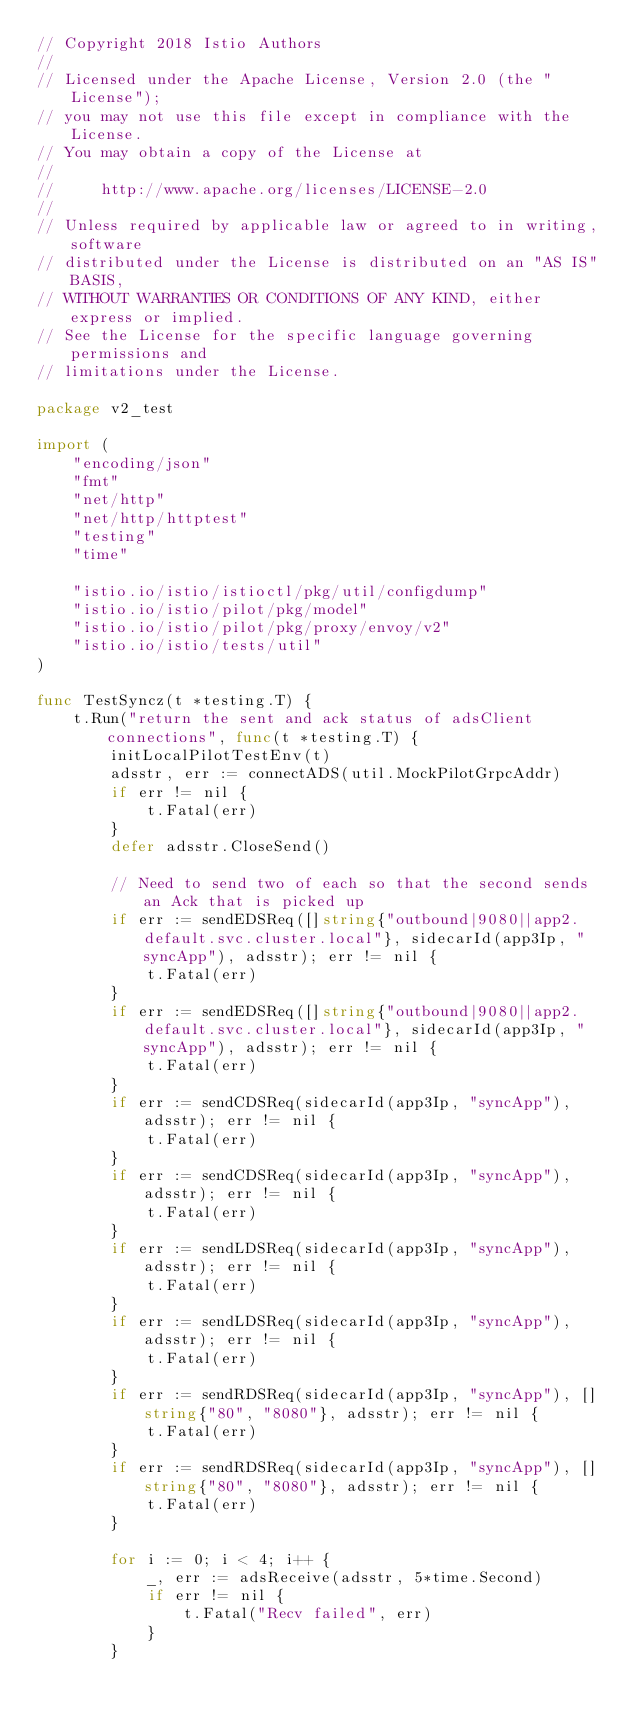Convert code to text. <code><loc_0><loc_0><loc_500><loc_500><_Go_>// Copyright 2018 Istio Authors
//
// Licensed under the Apache License, Version 2.0 (the "License");
// you may not use this file except in compliance with the License.
// You may obtain a copy of the License at
//
//     http://www.apache.org/licenses/LICENSE-2.0
//
// Unless required by applicable law or agreed to in writing, software
// distributed under the License is distributed on an "AS IS" BASIS,
// WITHOUT WARRANTIES OR CONDITIONS OF ANY KIND, either express or implied.
// See the License for the specific language governing permissions and
// limitations under the License.

package v2_test

import (
	"encoding/json"
	"fmt"
	"net/http"
	"net/http/httptest"
	"testing"
	"time"

	"istio.io/istio/istioctl/pkg/util/configdump"
	"istio.io/istio/pilot/pkg/model"
	"istio.io/istio/pilot/pkg/proxy/envoy/v2"
	"istio.io/istio/tests/util"
)

func TestSyncz(t *testing.T) {
	t.Run("return the sent and ack status of adsClient connections", func(t *testing.T) {
		initLocalPilotTestEnv(t)
		adsstr, err := connectADS(util.MockPilotGrpcAddr)
		if err != nil {
			t.Fatal(err)
		}
		defer adsstr.CloseSend()

		// Need to send two of each so that the second sends an Ack that is picked up
		if err := sendEDSReq([]string{"outbound|9080||app2.default.svc.cluster.local"}, sidecarId(app3Ip, "syncApp"), adsstr); err != nil {
			t.Fatal(err)
		}
		if err := sendEDSReq([]string{"outbound|9080||app2.default.svc.cluster.local"}, sidecarId(app3Ip, "syncApp"), adsstr); err != nil {
			t.Fatal(err)
		}
		if err := sendCDSReq(sidecarId(app3Ip, "syncApp"), adsstr); err != nil {
			t.Fatal(err)
		}
		if err := sendCDSReq(sidecarId(app3Ip, "syncApp"), adsstr); err != nil {
			t.Fatal(err)
		}
		if err := sendLDSReq(sidecarId(app3Ip, "syncApp"), adsstr); err != nil {
			t.Fatal(err)
		}
		if err := sendLDSReq(sidecarId(app3Ip, "syncApp"), adsstr); err != nil {
			t.Fatal(err)
		}
		if err := sendRDSReq(sidecarId(app3Ip, "syncApp"), []string{"80", "8080"}, adsstr); err != nil {
			t.Fatal(err)
		}
		if err := sendRDSReq(sidecarId(app3Ip, "syncApp"), []string{"80", "8080"}, adsstr); err != nil {
			t.Fatal(err)
		}

		for i := 0; i < 4; i++ {
			_, err := adsReceive(adsstr, 5*time.Second)
			if err != nil {
				t.Fatal("Recv failed", err)
			}
		}</code> 